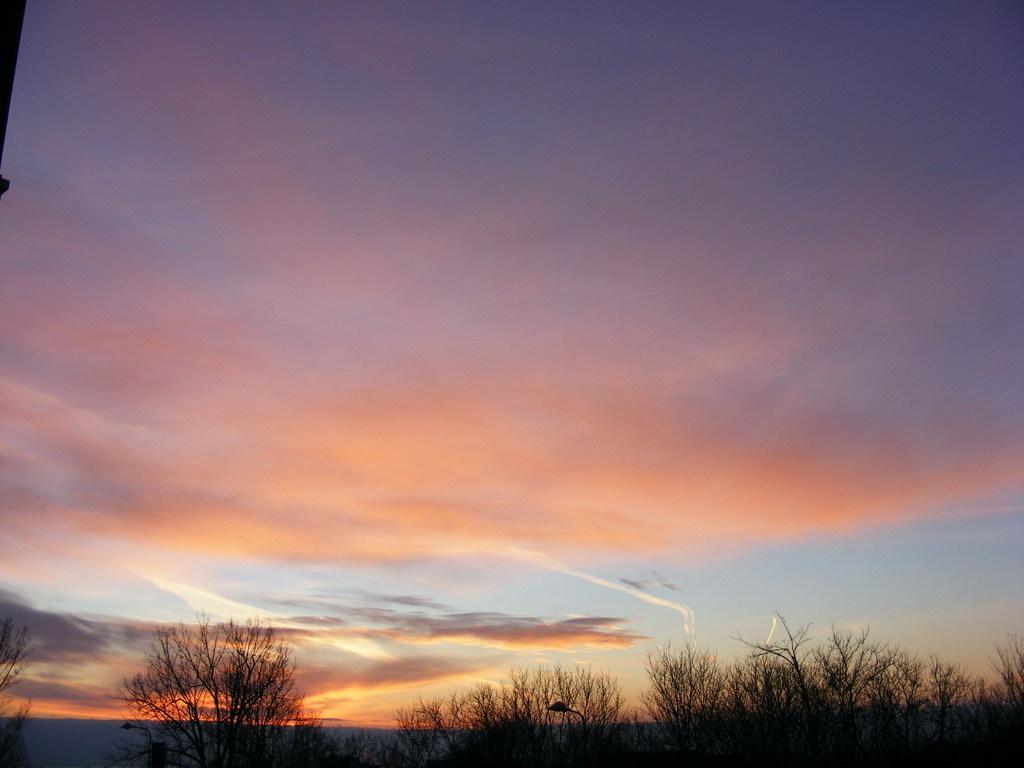Describe this image in one or two sentences. In this image we can see a few trees and a light pole and the sky with clouds at the top. 